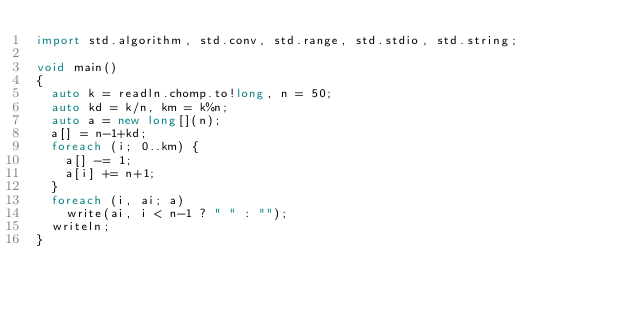Convert code to text. <code><loc_0><loc_0><loc_500><loc_500><_D_>import std.algorithm, std.conv, std.range, std.stdio, std.string;

void main()
{
  auto k = readln.chomp.to!long, n = 50;
  auto kd = k/n, km = k%n;
  auto a = new long[](n);
  a[] = n-1+kd;
  foreach (i; 0..km) {
    a[] -= 1;
    a[i] += n+1;
  }
  foreach (i, ai; a)
    write(ai, i < n-1 ? " " : "");
  writeln;
}
</code> 